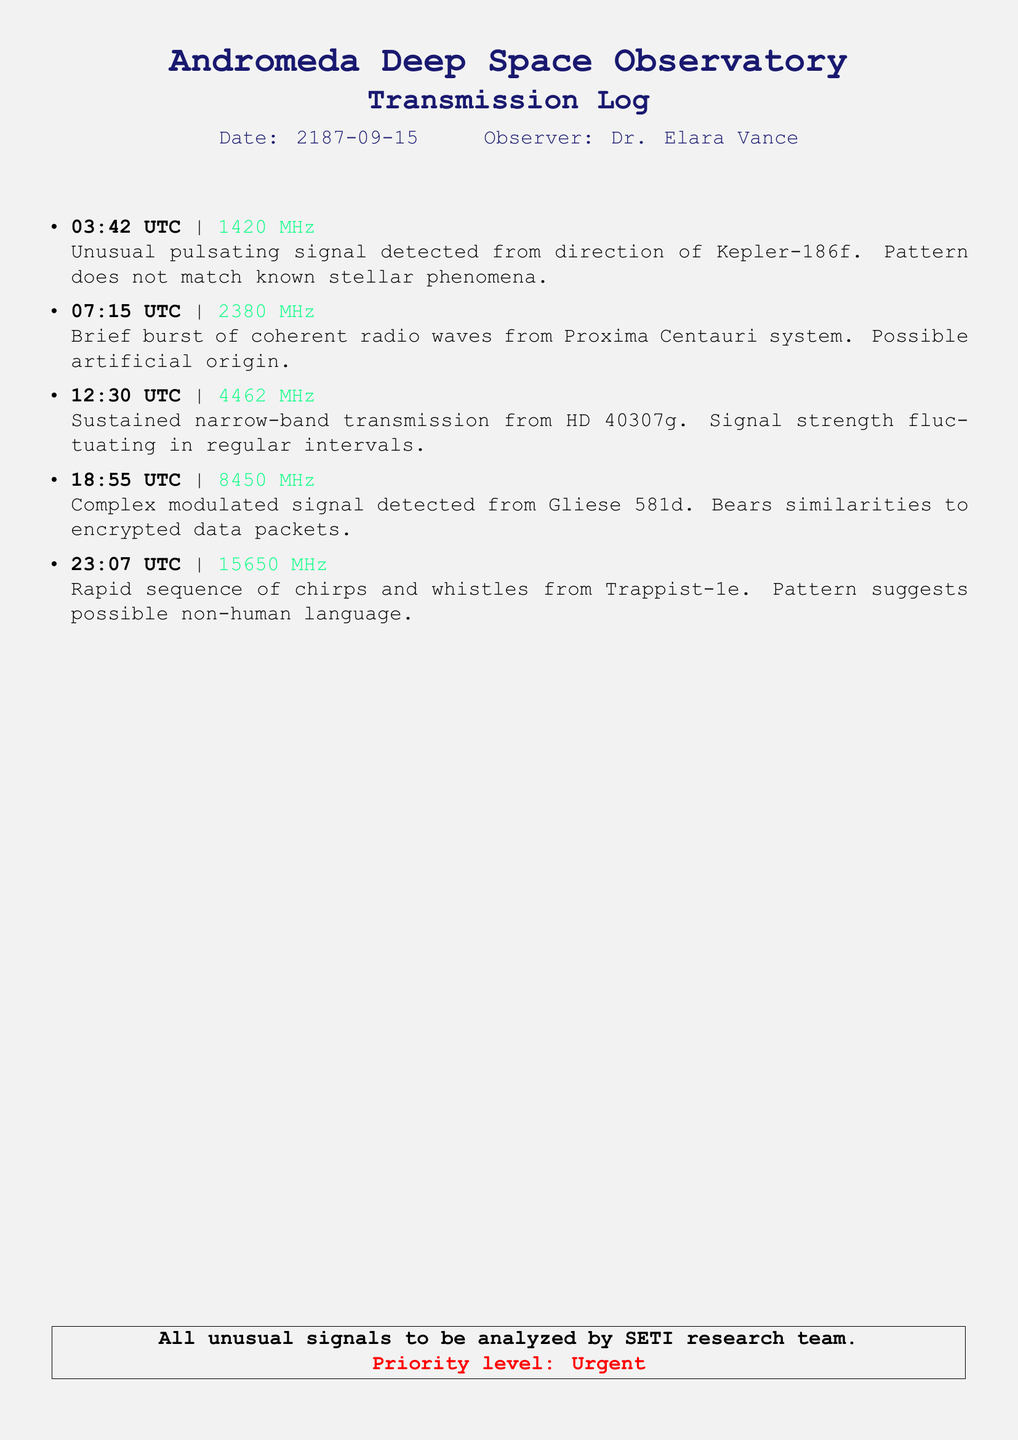What is the date of the transmission log? The date is clearly stated at the top of the document, which is 2187-09-15.
Answer: 2187-09-15 Who is the observer of the log? The observer's name appears right below the date, listed as Dr. Elara Vance.
Answer: Dr. Elara Vance What is the frequency of the first signal recorded? The first signal's frequency is specified at the beginning of the first entry, which is 1420 MHz.
Answer: 1420 MHz Which celestial body was associated with the unusual pulsating signal? The document states that the unusual pulsating signal was detected from the direction of Kepler-186f.
Answer: Kepler-186f What is the priority level mentioned for analyzing the signals? The document has a note indicating the priority level, which is stated as Urgent.
Answer: Urgent How many signals were recorded in total? By counting the listed signals in the transmission log, there is a total of five signals noted.
Answer: 5 What similarities does the signal from Gliese 581d have with data? The document mentions that the signal bears similarities to encrypted data packets.
Answer: encrypted data packets Which planet's signals suggest a possible non-human language? The rapid sequence of chirps and whistles from Trappist-1e indicates a possibility of a non-human language.
Answer: Trappist-1e What was the signal strength fluctuation pattern associated with? The sustained narrow-band transmission from HD 40307g exhibited a pattern of fluctuating signal strength.
Answer: HD 40307g 